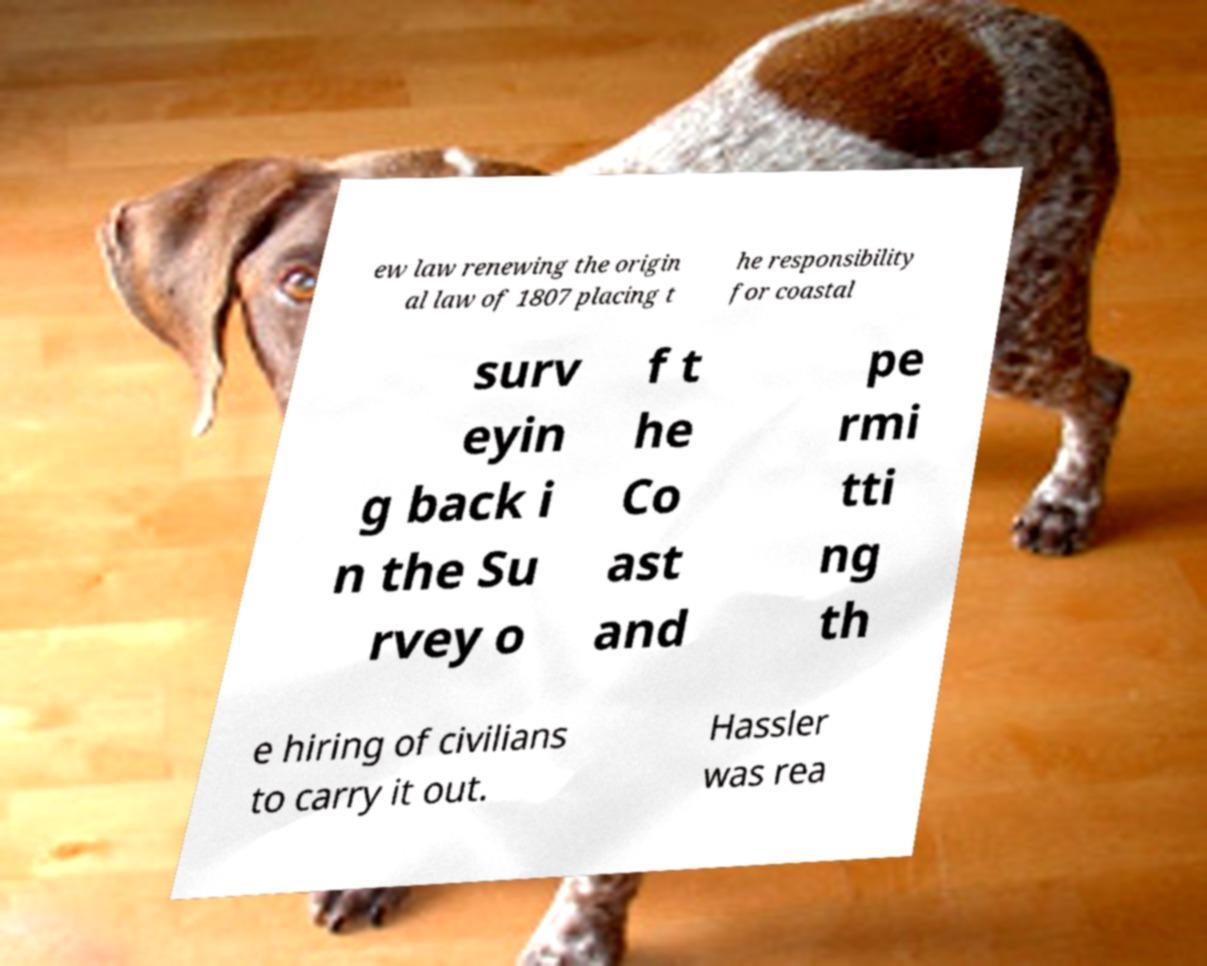Can you accurately transcribe the text from the provided image for me? ew law renewing the origin al law of 1807 placing t he responsibility for coastal surv eyin g back i n the Su rvey o f t he Co ast and pe rmi tti ng th e hiring of civilians to carry it out. Hassler was rea 